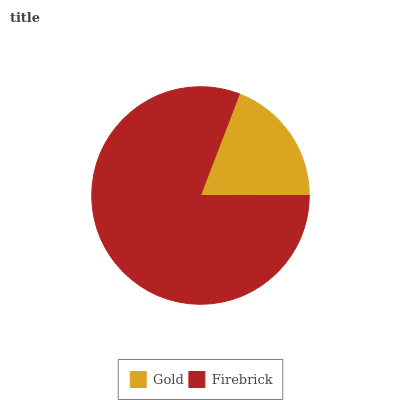Is Gold the minimum?
Answer yes or no. Yes. Is Firebrick the maximum?
Answer yes or no. Yes. Is Firebrick the minimum?
Answer yes or no. No. Is Firebrick greater than Gold?
Answer yes or no. Yes. Is Gold less than Firebrick?
Answer yes or no. Yes. Is Gold greater than Firebrick?
Answer yes or no. No. Is Firebrick less than Gold?
Answer yes or no. No. Is Firebrick the high median?
Answer yes or no. Yes. Is Gold the low median?
Answer yes or no. Yes. Is Gold the high median?
Answer yes or no. No. Is Firebrick the low median?
Answer yes or no. No. 